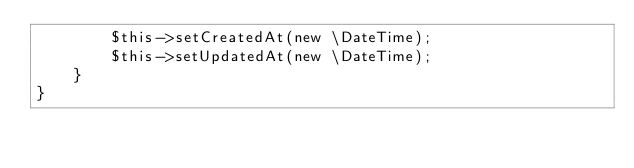Convert code to text. <code><loc_0><loc_0><loc_500><loc_500><_PHP_>        $this->setCreatedAt(new \DateTime);
        $this->setUpdatedAt(new \DateTime);
    }
}
</code> 